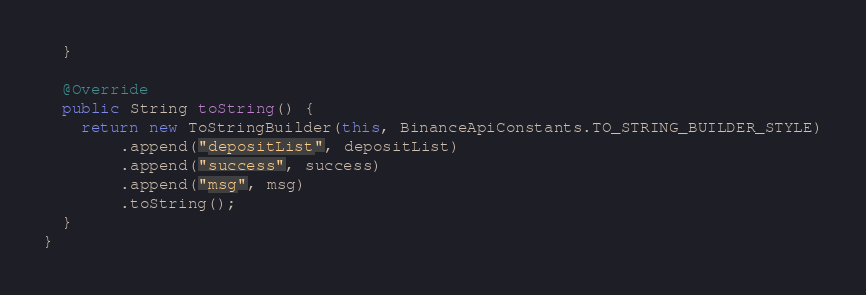Convert code to text. <code><loc_0><loc_0><loc_500><loc_500><_Java_>  }

  @Override
  public String toString() {
    return new ToStringBuilder(this, BinanceApiConstants.TO_STRING_BUILDER_STYLE)
        .append("depositList", depositList)
        .append("success", success)
        .append("msg", msg)
        .toString();
  }
}
</code> 